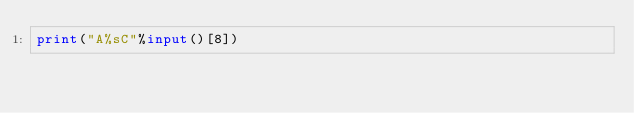Convert code to text. <code><loc_0><loc_0><loc_500><loc_500><_Python_>print("A%sC"%input()[8])</code> 